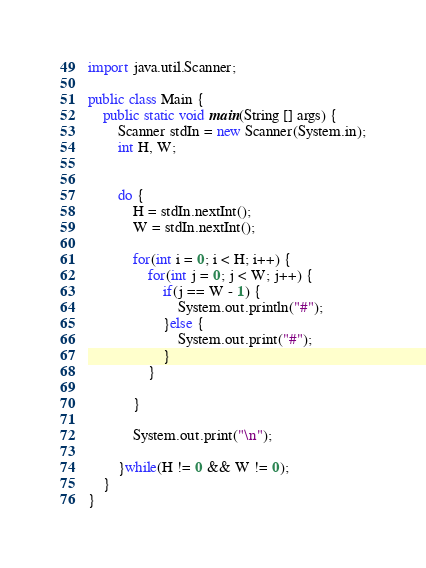<code> <loc_0><loc_0><loc_500><loc_500><_Java_>import java.util.Scanner;

public class Main {
	public static void main(String [] args) {
		Scanner stdIn = new Scanner(System.in);
		int H, W; 
		
		
		do {
			H = stdIn.nextInt();
			W = stdIn.nextInt();
			
			for(int i = 0; i < H; i++) {
				for(int j = 0; j < W; j++) {
					if(j == W - 1) {
						System.out.println("#");
					}else {
						System.out.print("#");
					}
				}
		
			}
			
			System.out.print("\n");
			
		}while(H != 0 && W != 0);			
	}
}

</code> 